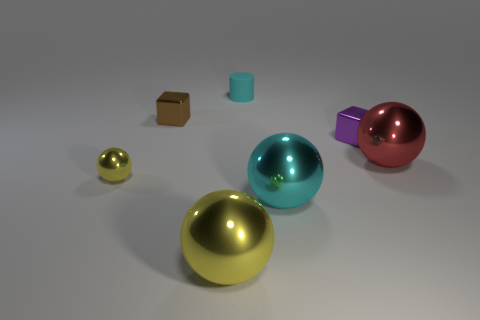Add 2 big cubes. How many objects exist? 9 Subtract all cylinders. How many objects are left? 6 Add 6 big balls. How many big balls exist? 9 Subtract 0 green balls. How many objects are left? 7 Subtract all cylinders. Subtract all tiny yellow spheres. How many objects are left? 5 Add 1 large yellow objects. How many large yellow objects are left? 2 